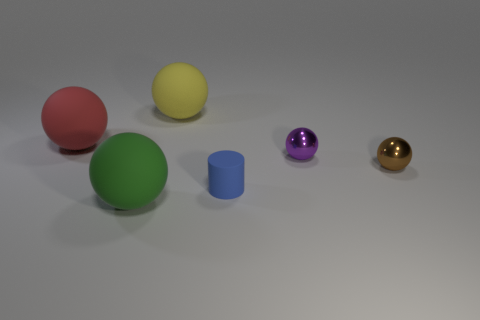Subtract all large green matte balls. How many balls are left? 4 Subtract 1 balls. How many balls are left? 4 Subtract all yellow spheres. How many spheres are left? 4 Add 1 tiny purple cylinders. How many objects exist? 7 Subtract all blue spheres. Subtract all gray cubes. How many spheres are left? 5 Subtract all balls. How many objects are left? 1 Subtract all rubber spheres. Subtract all metallic balls. How many objects are left? 1 Add 5 tiny purple objects. How many tiny purple objects are left? 6 Add 2 purple spheres. How many purple spheres exist? 3 Subtract 0 gray balls. How many objects are left? 6 